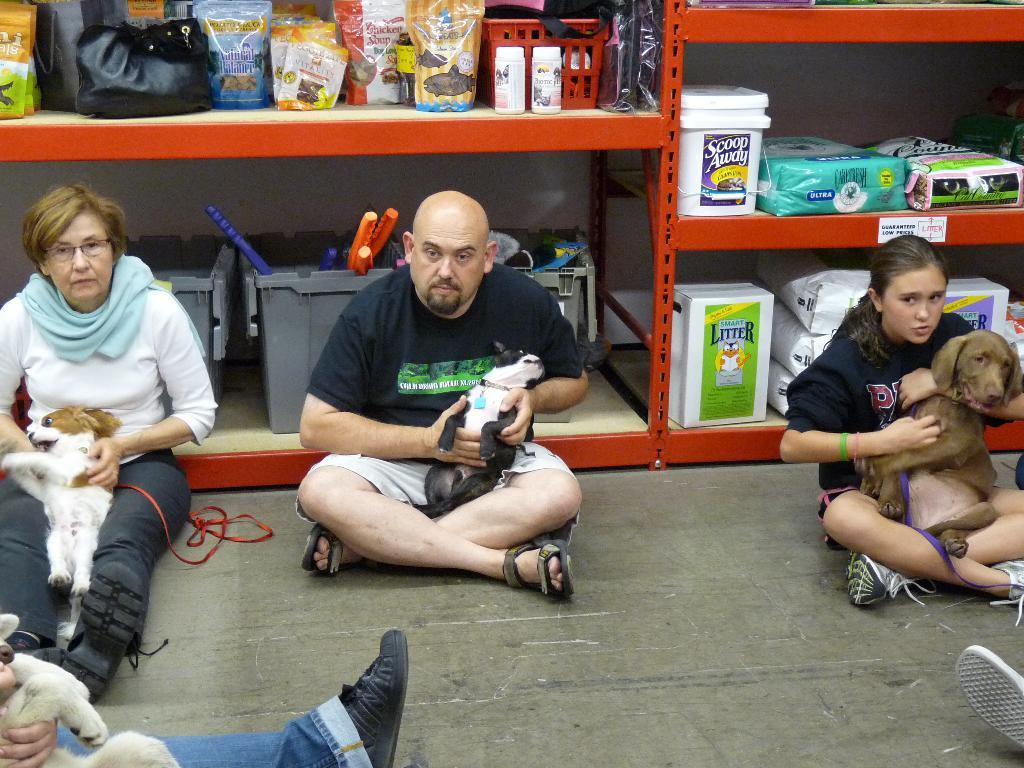What are the people in the image doing? The people in the image are sitting on the ground. What other living beings can be seen in the image? There are animals present in the image. What can be found on the shelf in the image? There is a shelf with food items in the image. What type of crime is being committed in the image? There is no crime being committed in the image; it features people sitting on the ground and animals. How does the train move through the image? There is no train present in the image. 